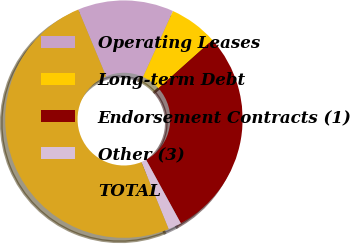Convert chart. <chart><loc_0><loc_0><loc_500><loc_500><pie_chart><fcel>Operating Leases<fcel>Long-term Debt<fcel>Endorsement Contracts (1)<fcel>Other (3)<fcel>TOTAL<nl><fcel>13.07%<fcel>6.61%<fcel>28.64%<fcel>1.81%<fcel>49.87%<nl></chart> 